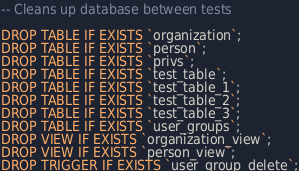<code> <loc_0><loc_0><loc_500><loc_500><_SQL_>-- Cleans up database between tests

DROP TABLE IF EXISTS `organization`;
DROP TABLE IF EXISTS `person`;
DROP TABLE IF EXISTS `privs`;
DROP TABLE IF EXISTS `test_table`;
DROP TABLE IF EXISTS `test_table_1`;
DROP TABLE IF EXISTS `test_table_2`;
DROP TABLE IF EXISTS `test_table_3`;
DROP TABLE IF EXISTS `user_groups`;
DROP VIEW IF EXISTS `organization_view`;
DROP VIEW IF EXISTS `person_view`;
DROP TRIGGER IF EXISTS `user_group_delete`;
</code> 